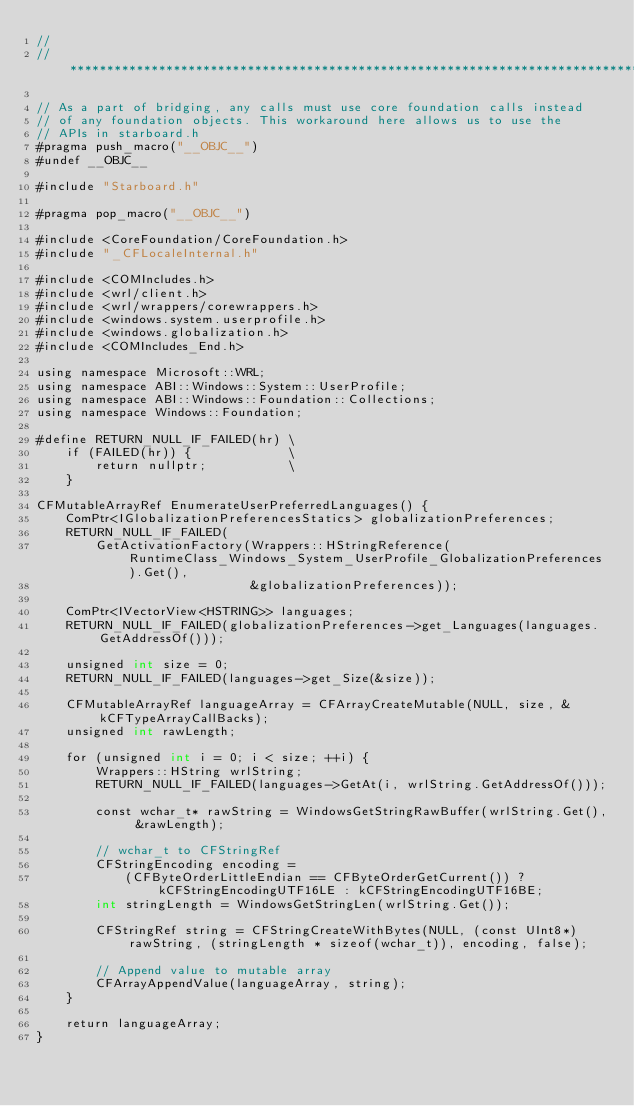Convert code to text. <code><loc_0><loc_0><loc_500><loc_500><_ObjectiveC_>//
//******************************************************************************

// As a part of bridging, any calls must use core foundation calls instead
// of any foundation objects. This workaround here allows us to use the
// APIs in starboard.h
#pragma push_macro("__OBJC__")
#undef __OBJC__

#include "Starboard.h"

#pragma pop_macro("__OBJC__")

#include <CoreFoundation/CoreFoundation.h>
#include "_CFLocaleInternal.h"

#include <COMIncludes.h>
#include <wrl/client.h>
#include <wrl/wrappers/corewrappers.h>
#include <windows.system.userprofile.h>
#include <windows.globalization.h>
#include <COMIncludes_End.h>

using namespace Microsoft::WRL;
using namespace ABI::Windows::System::UserProfile;
using namespace ABI::Windows::Foundation::Collections;
using namespace Windows::Foundation;

#define RETURN_NULL_IF_FAILED(hr) \
    if (FAILED(hr)) {             \
        return nullptr;           \
    }

CFMutableArrayRef EnumerateUserPreferredLanguages() {
    ComPtr<IGlobalizationPreferencesStatics> globalizationPreferences;
    RETURN_NULL_IF_FAILED(
        GetActivationFactory(Wrappers::HStringReference(RuntimeClass_Windows_System_UserProfile_GlobalizationPreferences).Get(),
                             &globalizationPreferences));

    ComPtr<IVectorView<HSTRING>> languages;
    RETURN_NULL_IF_FAILED(globalizationPreferences->get_Languages(languages.GetAddressOf()));

    unsigned int size = 0;
    RETURN_NULL_IF_FAILED(languages->get_Size(&size));

    CFMutableArrayRef languageArray = CFArrayCreateMutable(NULL, size, &kCFTypeArrayCallBacks);
    unsigned int rawLength;

    for (unsigned int i = 0; i < size; ++i) {
        Wrappers::HString wrlString;
        RETURN_NULL_IF_FAILED(languages->GetAt(i, wrlString.GetAddressOf()));

        const wchar_t* rawString = WindowsGetStringRawBuffer(wrlString.Get(), &rawLength);

        // wchar_t to CFStringRef
        CFStringEncoding encoding =
            (CFByteOrderLittleEndian == CFByteOrderGetCurrent()) ? kCFStringEncodingUTF16LE : kCFStringEncodingUTF16BE;
        int stringLength = WindowsGetStringLen(wrlString.Get());

        CFStringRef string = CFStringCreateWithBytes(NULL, (const UInt8*)rawString, (stringLength * sizeof(wchar_t)), encoding, false);

        // Append value to mutable array
        CFArrayAppendValue(languageArray, string);
    }

    return languageArray;
}</code> 